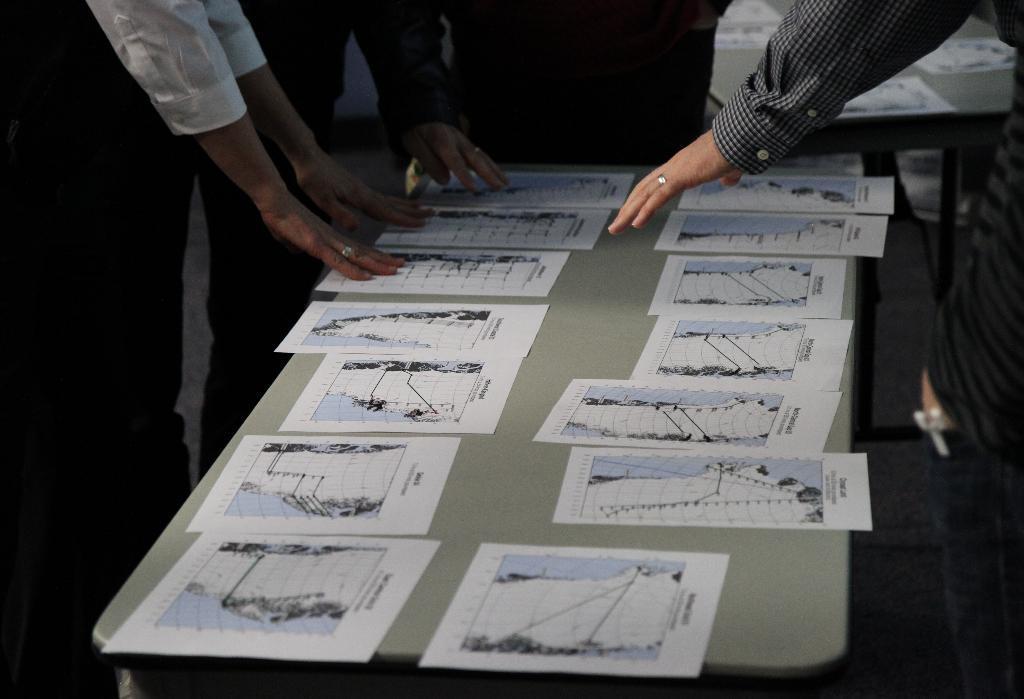Could you give a brief overview of what you see in this image? In the center of the image we can see papers on the table and we can also persons around the table. In the background we can see table and papers. 